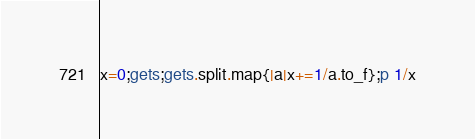Convert code to text. <code><loc_0><loc_0><loc_500><loc_500><_Ruby_>x=0;gets;gets.split.map{|a|x+=1/a.to_f};p 1/x</code> 